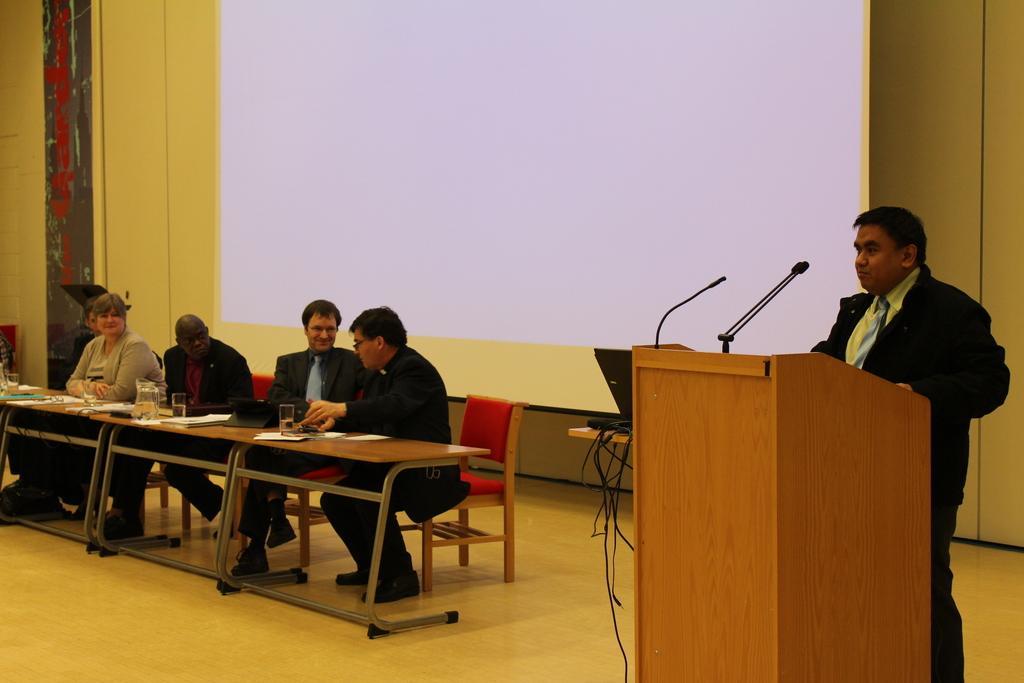Could you give a brief overview of what you see in this image? In this picture I can see few people seated on the chairs and I can see papers, glasses on the table and I can see a man standing at a podium and speaking with the help of microphones and I can see a projector screen in the back and it looks like a monitor on the table. 